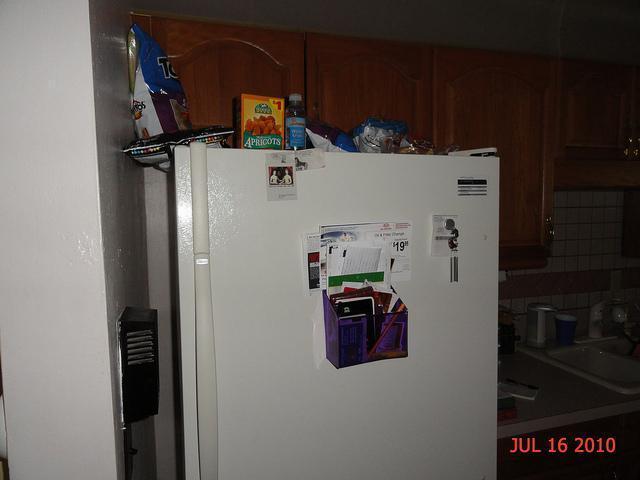How many people are in this room?
Give a very brief answer. 0. 